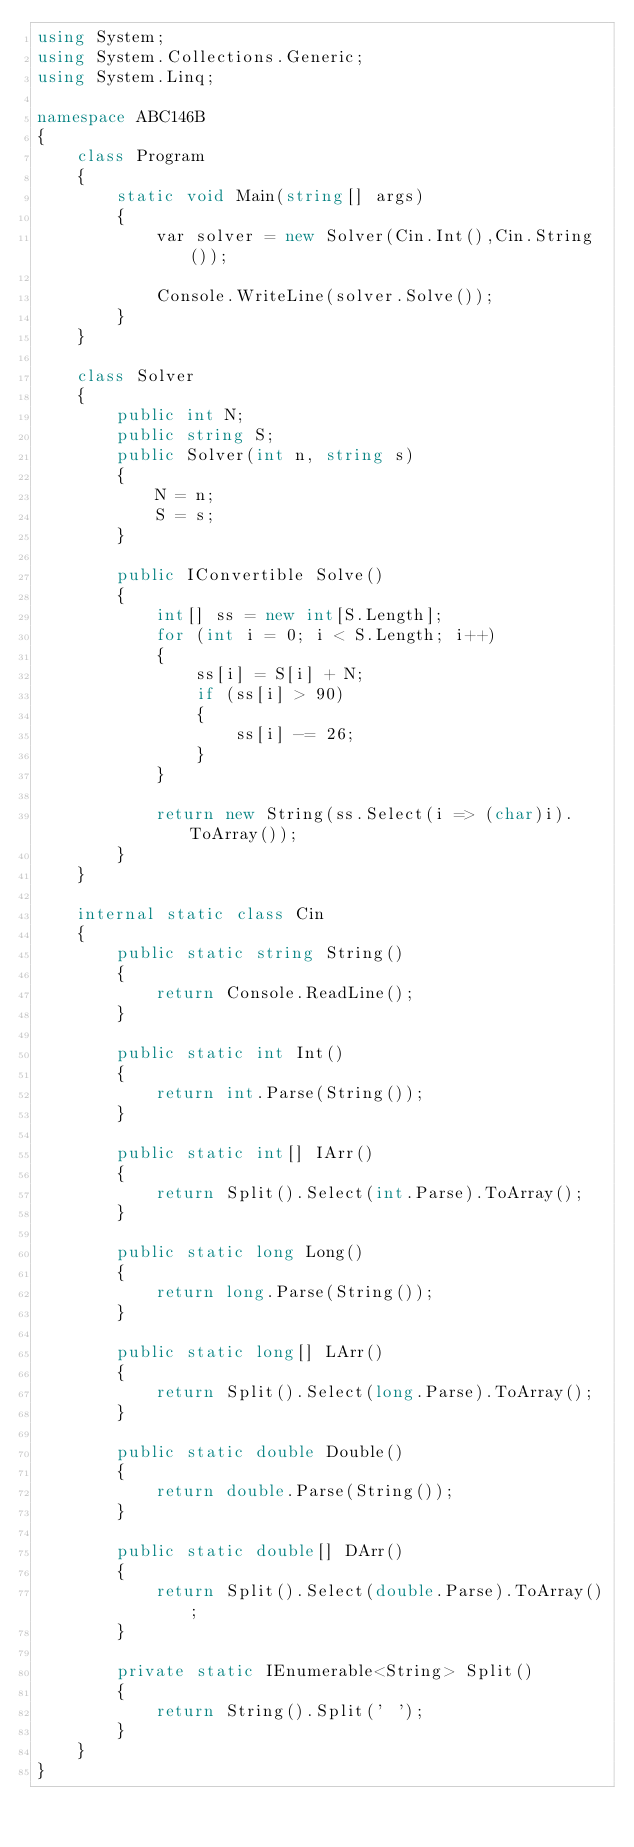Convert code to text. <code><loc_0><loc_0><loc_500><loc_500><_C#_>using System;
using System.Collections.Generic;
using System.Linq;

namespace ABC146B
{
    class Program
    {
        static void Main(string[] args)
        {
            var solver = new Solver(Cin.Int(),Cin.String());

            Console.WriteLine(solver.Solve());
        }
    }

    class Solver
    {
        public int N;
        public string S;
        public Solver(int n, string s)
        {
            N = n;
            S = s;
        }

        public IConvertible Solve()
        {
            int[] ss = new int[S.Length];
            for (int i = 0; i < S.Length; i++)
            {
                ss[i] = S[i] + N;
                if (ss[i] > 90)
                {
                    ss[i] -= 26;
                }
            }

            return new String(ss.Select(i => (char)i).ToArray());
        }
    }

    internal static class Cin
    {
        public static string String()
        {
            return Console.ReadLine();
        }

        public static int Int()
        {
            return int.Parse(String());
        }

        public static int[] IArr()
        {
            return Split().Select(int.Parse).ToArray();
        }

        public static long Long()
        {
            return long.Parse(String());
        }

        public static long[] LArr()
        {
            return Split().Select(long.Parse).ToArray();
        }

        public static double Double()
        {
            return double.Parse(String());
        }

        public static double[] DArr()
        {
            return Split().Select(double.Parse).ToArray();
        }

        private static IEnumerable<String> Split()
        {
            return String().Split(' ');
        }
    }
}</code> 